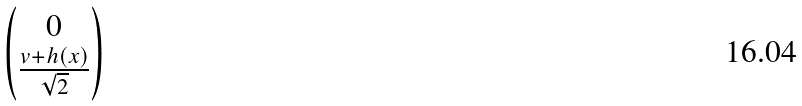Convert formula to latex. <formula><loc_0><loc_0><loc_500><loc_500>\begin{pmatrix} 0 \\ \frac { v + h ( x ) } { \sqrt { 2 } } \end{pmatrix}</formula> 